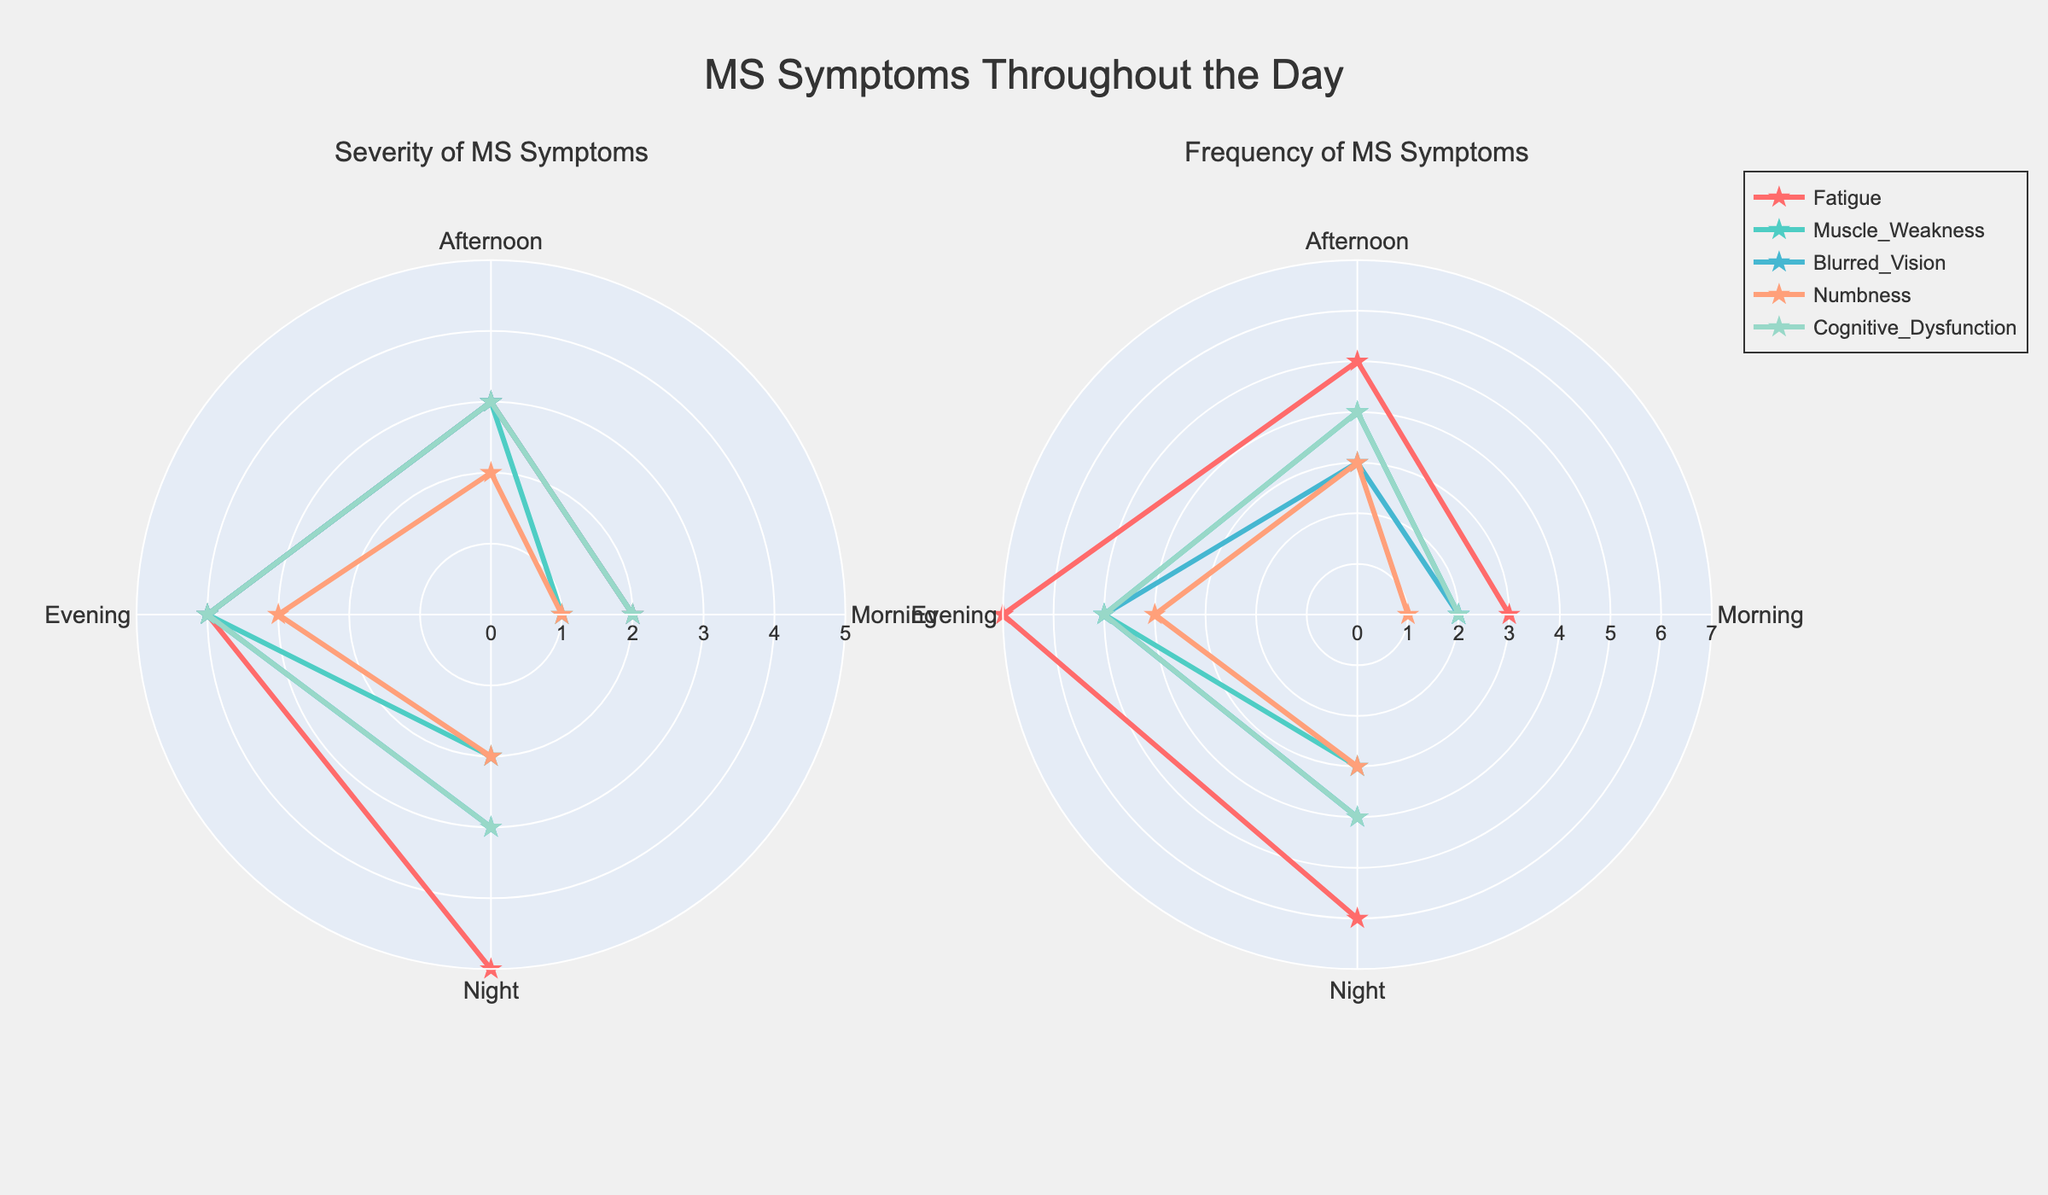How many different symptoms are shown in the figure? There are five different symptoms listed in the data: Fatigue, Muscle Weakness, Blurred Vision, Numbness, and Cognitive Dysfunction. These are represented by different colors in the plot.
Answer: Five Which symptom has the highest severity at night? By observing the "Severity of MS Symptoms" subplot, we can see that Fatigue has the highest value of severity, which is 5, at night.
Answer: Fatigue How does the frequency of Blurred Vision change throughout the day? In the "Frequency of MS Symptoms" subplot, Blurred Vision's frequency values are 2 in the morning, 3 in the afternoon, 5 in the evening, and 4 at night.
Answer: It increases from morning to evening and slightly decreases at night What's the average severity of Muscle Weakness throughout the day? The severity values for Muscle Weakness are 1 in the morning, 3 in the afternoon, 4 in the evening, and 2 at night. Adding these values, we get 1+3+4+2=10. Dividing by 4 (the number of times of the day), the average severity is 10/4 = 2.5.
Answer: 2.5 Which symptom's frequency peaks in the evening? Observing the "Frequency of MS Symptoms" subplot, Fatigue has the highest frequency in the evening, with a value of 7.
Answer: Fatigue Is the severity of Cognitive Dysfunction higher in the afternoon or night? In the "Severity of MS Symptoms" subplot, Cognitive Dysfunction has a severity of 3 in the afternoon and a severity of 3 at night. Both times have the same severity.
Answer: Same Between Fatigue and Numbness, which symptom shows a greater change in severity from morning to night? The severity of Fatigue changes from 2 in the morning to 5 at night, a change of 3. Numbness changes from 1 in the morning to 2 at night, a change of 1. Therefore, Fatigue shows a greater change in severity.
Answer: Fatigue What is the total frequency of Muscle Weakness during the whole day? The frequency values for Muscle Weakness are 2 in the morning, 4 in the afternoon, 5 in the evening, and 3 at night. Adding these values, we get 2+4+5+3=14.
Answer: 14 Which symptom has the least severity in the morning? Observing the "Severity of MS Symptoms" subplot, Muscle Weakness and Numbness both have the lowest severity in the morning with a value of 1.
Answer: Muscle Weakness and Numbness Which symptom has a consistency in its frequency pattern throughout the day? By reviewing the "Frequency of MS Symptoms" subplot, Numbness has a more consistent frequency pattern with values of 1 in the morning, 3 in the afternoon, 4 in the evening, and 3 at night.
Answer: Numbness 